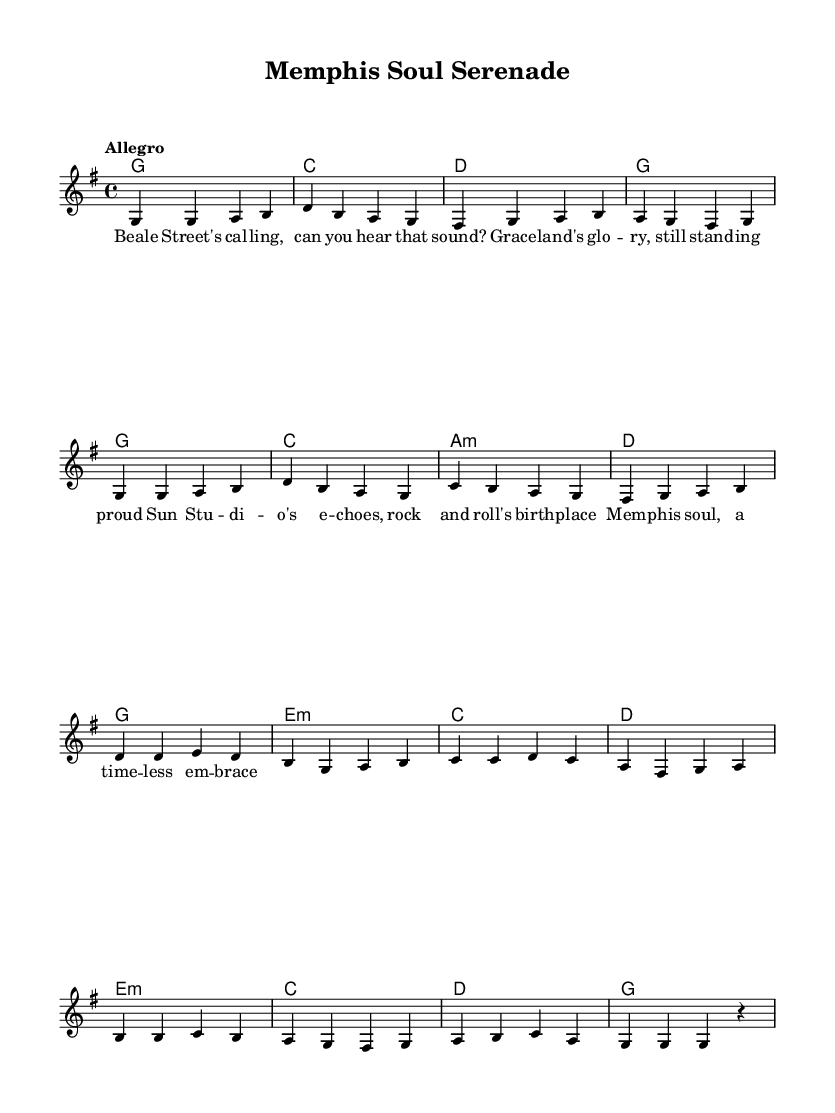What is the key signature of this music? The key signature is G major, which has one sharp (F#). You can find this information at the beginning of the score, right after the clef symbol.
Answer: G major What is the time signature used in the piece? The time signature is 4/4, which indicates four beats per measure. This is noted after the key signature and is a common time signature in popular music.
Answer: 4/4 What is the tempo marking of this piece? The tempo marking is Allegro, which suggests a fast and lively pace for the performance. The tempo indication is written above the staff.
Answer: Allegro How many measures are in the melody section? The melody section contains a total of 16 measures, which can be counted by looking at the vertical bar lines dividing the staff.
Answer: 16 What chord is played at the beginning of the piece? The first chord is G major, which is indicated by the chord symbol at the start of the score under the melody. The chord changes are shown in a block format accompanying the music.
Answer: G How many different chords are used in total throughout the piece? There are 8 different chords used throughout the piece: G, C, D, A minor, E minor. This can be determined by examining the chord symbols written above the staff as they progress through the measures.
Answer: 8 What is the last note of the melody? The last note of the melody is a rest, indicated by the letter "r," which signifies a pause or silence in the music at the end of the last measure.
Answer: r 